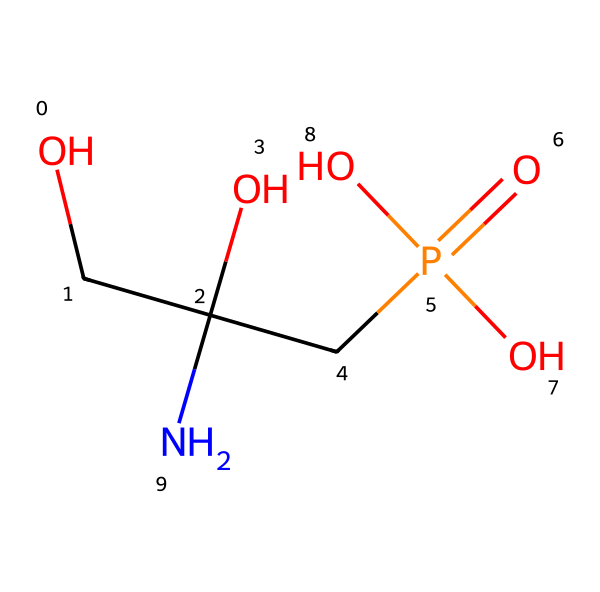How many carbon atoms are present in glyphosate? In the SMILES representation, "OCC(O)(CP(=O)(O)O)N", we can identify the carbon atoms represented by "C" in the structure. Counting each "C" gives us a total of three carbon atoms.
Answer: three What is the molecular formula of glyphosate? By gathering all the atoms present in the SMILES, we have 3 carbon (C), 8 hydrogen (H), 1 nitrogen (N), 4 oxygen (O), and 1 phosphorus (P) atom, leading to the molecular formula C3H8N1O4P1.
Answer: C3H8N1O4P1 Which functional group is indicated by the “P(=O)(O)O” part of the structure? This portion indicates the presence of a phosphate group, characterized by the phosphorus atom bonded to four oxygens, one of which is a double bond (the “=O”).
Answer: phosphate group How many oxygen atoms are present in glyphosate? The SMILES notation shows "O" present in two contexts: directly as single oxygen atoms and as part of the phosphate group. Counting these gives us four oxygen atoms in total.
Answer: four What is the role of nitrogen in glyphosate? The nitrogen atom, indicated by "N" in the structure, is typically associated with the amine functional group, which plays a critical role in the herbicidal activity of glyphosate.
Answer: herbicidal activity What type of chemical is glyphosate? Glyphosate is classified as an herbicide, specifically a systemic herbicide utilized for controlling weeds in agricultural practices.
Answer: herbicide 